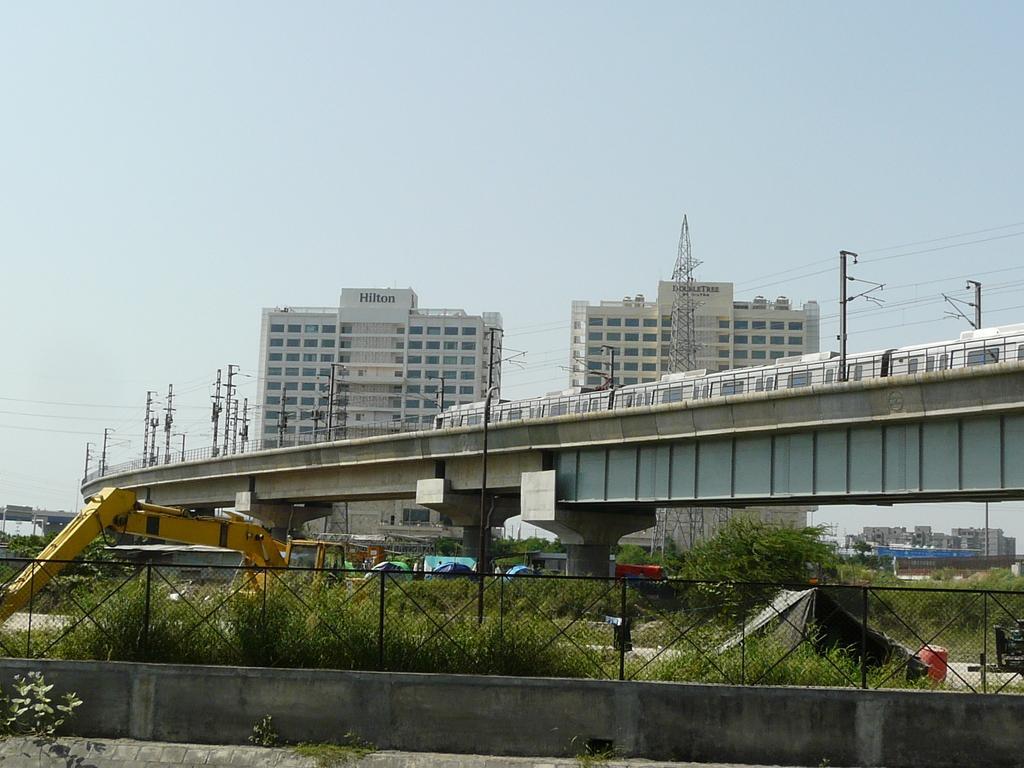Describe this image in one or two sentences. An outdoor picture. Sky is in blue color. Far there are buildings with windows. This is a bridge. Train is travelling over the bridge. This is a crane in yellow color. Far there are trees. Fence is in black color. Tower. 